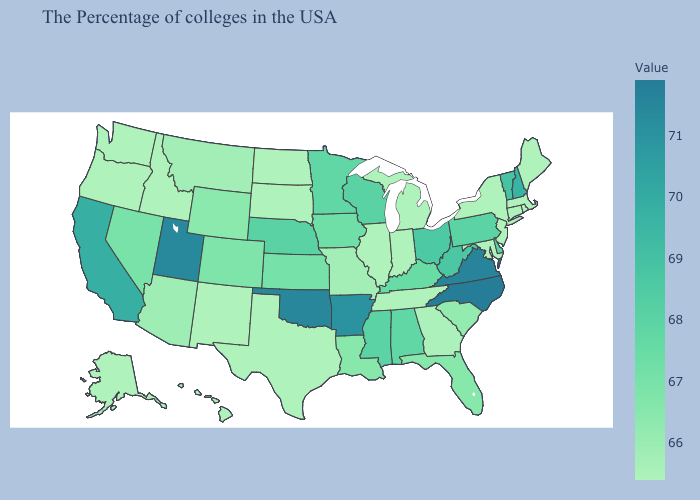Which states hav the highest value in the South?
Quick response, please. North Carolina. Does Utah have the highest value in the West?
Quick response, please. Yes. Does the map have missing data?
Be succinct. No. Does Maryland have the lowest value in the USA?
Short answer required. Yes. Among the states that border Illinois , does Wisconsin have the lowest value?
Give a very brief answer. No. 